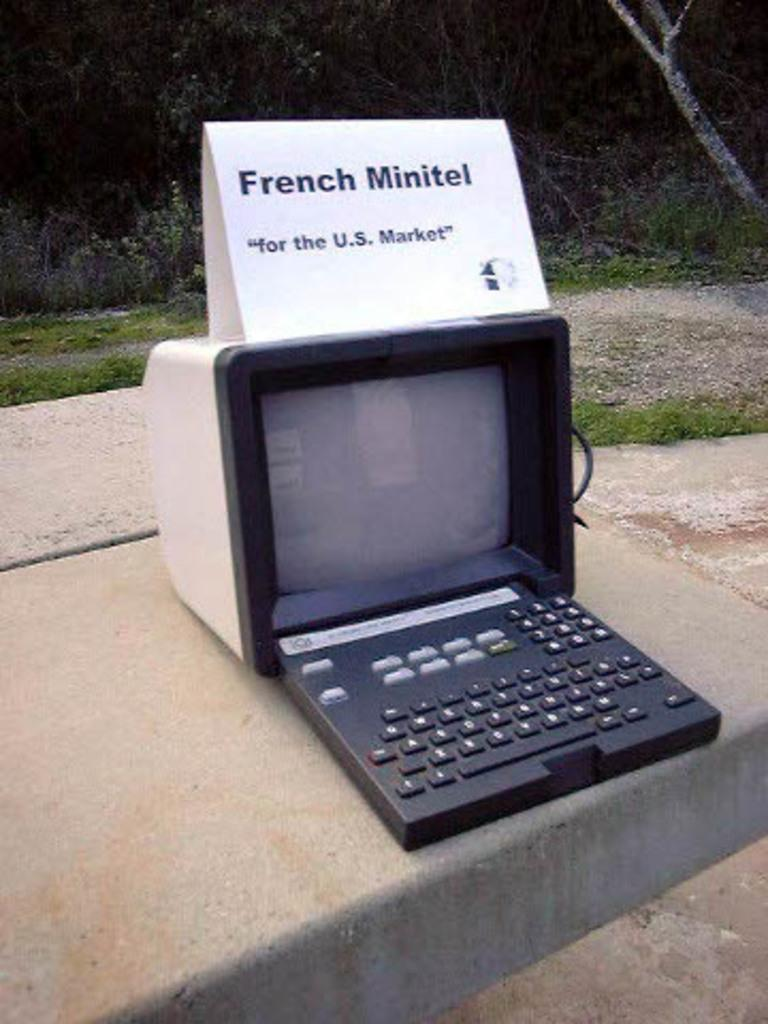<image>
Describe the image concisely. An old fashioned computer on a sidewalk with a sign that says French Minitel. 